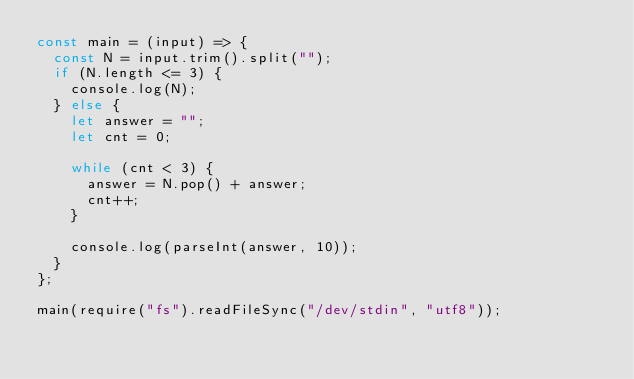<code> <loc_0><loc_0><loc_500><loc_500><_JavaScript_>const main = (input) => {
  const N = input.trim().split("");
  if (N.length <= 3) {
    console.log(N);
  } else {
    let answer = "";
    let cnt = 0;

    while (cnt < 3) {
      answer = N.pop() + answer;
      cnt++;
    }

    console.log(parseInt(answer, 10));
  }
};

main(require("fs").readFileSync("/dev/stdin", "utf8"));</code> 